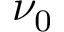<formula> <loc_0><loc_0><loc_500><loc_500>\nu _ { 0 }</formula> 